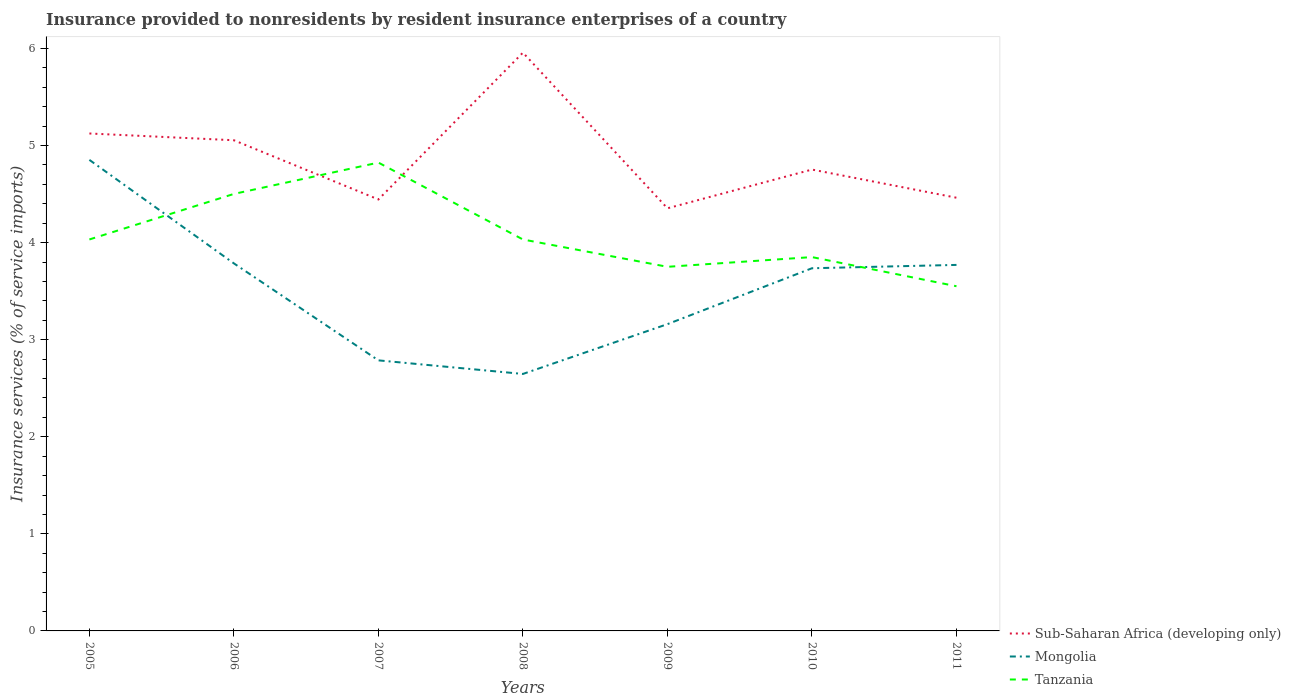How many different coloured lines are there?
Offer a very short reply. 3. Is the number of lines equal to the number of legend labels?
Offer a terse response. Yes. Across all years, what is the maximum insurance provided to nonresidents in Sub-Saharan Africa (developing only)?
Keep it short and to the point. 4.35. What is the total insurance provided to nonresidents in Tanzania in the graph?
Your answer should be very brief. 0.97. What is the difference between the highest and the second highest insurance provided to nonresidents in Tanzania?
Your answer should be compact. 1.27. Is the insurance provided to nonresidents in Tanzania strictly greater than the insurance provided to nonresidents in Mongolia over the years?
Your response must be concise. No. How many lines are there?
Your answer should be compact. 3. How many years are there in the graph?
Give a very brief answer. 7. Does the graph contain any zero values?
Provide a short and direct response. No. Where does the legend appear in the graph?
Provide a succinct answer. Bottom right. How many legend labels are there?
Provide a short and direct response. 3. What is the title of the graph?
Your answer should be compact. Insurance provided to nonresidents by resident insurance enterprises of a country. Does "Oman" appear as one of the legend labels in the graph?
Provide a succinct answer. No. What is the label or title of the X-axis?
Keep it short and to the point. Years. What is the label or title of the Y-axis?
Ensure brevity in your answer.  Insurance services (% of service imports). What is the Insurance services (% of service imports) in Sub-Saharan Africa (developing only) in 2005?
Provide a succinct answer. 5.12. What is the Insurance services (% of service imports) of Mongolia in 2005?
Offer a terse response. 4.85. What is the Insurance services (% of service imports) in Tanzania in 2005?
Offer a terse response. 4.03. What is the Insurance services (% of service imports) in Sub-Saharan Africa (developing only) in 2006?
Provide a succinct answer. 5.05. What is the Insurance services (% of service imports) in Mongolia in 2006?
Give a very brief answer. 3.79. What is the Insurance services (% of service imports) in Tanzania in 2006?
Give a very brief answer. 4.5. What is the Insurance services (% of service imports) of Sub-Saharan Africa (developing only) in 2007?
Give a very brief answer. 4.44. What is the Insurance services (% of service imports) in Mongolia in 2007?
Offer a terse response. 2.79. What is the Insurance services (% of service imports) of Tanzania in 2007?
Offer a terse response. 4.82. What is the Insurance services (% of service imports) in Sub-Saharan Africa (developing only) in 2008?
Your answer should be compact. 5.96. What is the Insurance services (% of service imports) in Mongolia in 2008?
Keep it short and to the point. 2.65. What is the Insurance services (% of service imports) in Tanzania in 2008?
Make the answer very short. 4.03. What is the Insurance services (% of service imports) in Sub-Saharan Africa (developing only) in 2009?
Your answer should be compact. 4.35. What is the Insurance services (% of service imports) of Mongolia in 2009?
Give a very brief answer. 3.16. What is the Insurance services (% of service imports) of Tanzania in 2009?
Keep it short and to the point. 3.75. What is the Insurance services (% of service imports) of Sub-Saharan Africa (developing only) in 2010?
Your response must be concise. 4.75. What is the Insurance services (% of service imports) of Mongolia in 2010?
Offer a very short reply. 3.74. What is the Insurance services (% of service imports) in Tanzania in 2010?
Ensure brevity in your answer.  3.85. What is the Insurance services (% of service imports) in Sub-Saharan Africa (developing only) in 2011?
Offer a very short reply. 4.46. What is the Insurance services (% of service imports) of Mongolia in 2011?
Give a very brief answer. 3.77. What is the Insurance services (% of service imports) in Tanzania in 2011?
Make the answer very short. 3.55. Across all years, what is the maximum Insurance services (% of service imports) in Sub-Saharan Africa (developing only)?
Offer a terse response. 5.96. Across all years, what is the maximum Insurance services (% of service imports) of Mongolia?
Give a very brief answer. 4.85. Across all years, what is the maximum Insurance services (% of service imports) of Tanzania?
Ensure brevity in your answer.  4.82. Across all years, what is the minimum Insurance services (% of service imports) of Sub-Saharan Africa (developing only)?
Provide a succinct answer. 4.35. Across all years, what is the minimum Insurance services (% of service imports) of Mongolia?
Provide a succinct answer. 2.65. Across all years, what is the minimum Insurance services (% of service imports) of Tanzania?
Your answer should be very brief. 3.55. What is the total Insurance services (% of service imports) in Sub-Saharan Africa (developing only) in the graph?
Provide a short and direct response. 34.15. What is the total Insurance services (% of service imports) in Mongolia in the graph?
Your answer should be compact. 24.74. What is the total Insurance services (% of service imports) of Tanzania in the graph?
Give a very brief answer. 28.54. What is the difference between the Insurance services (% of service imports) in Sub-Saharan Africa (developing only) in 2005 and that in 2006?
Your answer should be very brief. 0.07. What is the difference between the Insurance services (% of service imports) of Mongolia in 2005 and that in 2006?
Keep it short and to the point. 1.07. What is the difference between the Insurance services (% of service imports) in Tanzania in 2005 and that in 2006?
Your answer should be compact. -0.47. What is the difference between the Insurance services (% of service imports) in Sub-Saharan Africa (developing only) in 2005 and that in 2007?
Provide a succinct answer. 0.68. What is the difference between the Insurance services (% of service imports) of Mongolia in 2005 and that in 2007?
Offer a terse response. 2.07. What is the difference between the Insurance services (% of service imports) in Tanzania in 2005 and that in 2007?
Offer a very short reply. -0.79. What is the difference between the Insurance services (% of service imports) of Sub-Saharan Africa (developing only) in 2005 and that in 2008?
Give a very brief answer. -0.83. What is the difference between the Insurance services (% of service imports) in Mongolia in 2005 and that in 2008?
Offer a very short reply. 2.21. What is the difference between the Insurance services (% of service imports) in Sub-Saharan Africa (developing only) in 2005 and that in 2009?
Offer a very short reply. 0.77. What is the difference between the Insurance services (% of service imports) in Mongolia in 2005 and that in 2009?
Provide a succinct answer. 1.69. What is the difference between the Insurance services (% of service imports) in Tanzania in 2005 and that in 2009?
Provide a short and direct response. 0.28. What is the difference between the Insurance services (% of service imports) of Sub-Saharan Africa (developing only) in 2005 and that in 2010?
Provide a short and direct response. 0.37. What is the difference between the Insurance services (% of service imports) of Mongolia in 2005 and that in 2010?
Your response must be concise. 1.12. What is the difference between the Insurance services (% of service imports) of Tanzania in 2005 and that in 2010?
Offer a very short reply. 0.18. What is the difference between the Insurance services (% of service imports) of Sub-Saharan Africa (developing only) in 2005 and that in 2011?
Provide a succinct answer. 0.66. What is the difference between the Insurance services (% of service imports) in Mongolia in 2005 and that in 2011?
Make the answer very short. 1.08. What is the difference between the Insurance services (% of service imports) in Tanzania in 2005 and that in 2011?
Ensure brevity in your answer.  0.48. What is the difference between the Insurance services (% of service imports) in Sub-Saharan Africa (developing only) in 2006 and that in 2007?
Provide a short and direct response. 0.61. What is the difference between the Insurance services (% of service imports) in Tanzania in 2006 and that in 2007?
Give a very brief answer. -0.32. What is the difference between the Insurance services (% of service imports) in Sub-Saharan Africa (developing only) in 2006 and that in 2008?
Make the answer very short. -0.9. What is the difference between the Insurance services (% of service imports) in Mongolia in 2006 and that in 2008?
Give a very brief answer. 1.14. What is the difference between the Insurance services (% of service imports) in Tanzania in 2006 and that in 2008?
Your answer should be compact. 0.47. What is the difference between the Insurance services (% of service imports) of Sub-Saharan Africa (developing only) in 2006 and that in 2009?
Keep it short and to the point. 0.7. What is the difference between the Insurance services (% of service imports) of Mongolia in 2006 and that in 2009?
Keep it short and to the point. 0.63. What is the difference between the Insurance services (% of service imports) in Tanzania in 2006 and that in 2009?
Make the answer very short. 0.75. What is the difference between the Insurance services (% of service imports) of Sub-Saharan Africa (developing only) in 2006 and that in 2010?
Keep it short and to the point. 0.3. What is the difference between the Insurance services (% of service imports) in Mongolia in 2006 and that in 2010?
Offer a terse response. 0.05. What is the difference between the Insurance services (% of service imports) of Tanzania in 2006 and that in 2010?
Ensure brevity in your answer.  0.65. What is the difference between the Insurance services (% of service imports) in Sub-Saharan Africa (developing only) in 2006 and that in 2011?
Your response must be concise. 0.59. What is the difference between the Insurance services (% of service imports) of Mongolia in 2006 and that in 2011?
Your response must be concise. 0.02. What is the difference between the Insurance services (% of service imports) in Tanzania in 2006 and that in 2011?
Ensure brevity in your answer.  0.95. What is the difference between the Insurance services (% of service imports) in Sub-Saharan Africa (developing only) in 2007 and that in 2008?
Keep it short and to the point. -1.51. What is the difference between the Insurance services (% of service imports) of Mongolia in 2007 and that in 2008?
Your answer should be compact. 0.14. What is the difference between the Insurance services (% of service imports) in Tanzania in 2007 and that in 2008?
Offer a very short reply. 0.79. What is the difference between the Insurance services (% of service imports) in Sub-Saharan Africa (developing only) in 2007 and that in 2009?
Offer a terse response. 0.09. What is the difference between the Insurance services (% of service imports) of Mongolia in 2007 and that in 2009?
Ensure brevity in your answer.  -0.37. What is the difference between the Insurance services (% of service imports) in Tanzania in 2007 and that in 2009?
Ensure brevity in your answer.  1.07. What is the difference between the Insurance services (% of service imports) of Sub-Saharan Africa (developing only) in 2007 and that in 2010?
Your answer should be compact. -0.31. What is the difference between the Insurance services (% of service imports) in Mongolia in 2007 and that in 2010?
Your answer should be compact. -0.95. What is the difference between the Insurance services (% of service imports) in Tanzania in 2007 and that in 2010?
Keep it short and to the point. 0.97. What is the difference between the Insurance services (% of service imports) of Sub-Saharan Africa (developing only) in 2007 and that in 2011?
Keep it short and to the point. -0.02. What is the difference between the Insurance services (% of service imports) in Mongolia in 2007 and that in 2011?
Offer a terse response. -0.98. What is the difference between the Insurance services (% of service imports) of Tanzania in 2007 and that in 2011?
Your answer should be compact. 1.27. What is the difference between the Insurance services (% of service imports) of Sub-Saharan Africa (developing only) in 2008 and that in 2009?
Keep it short and to the point. 1.6. What is the difference between the Insurance services (% of service imports) of Mongolia in 2008 and that in 2009?
Your answer should be compact. -0.51. What is the difference between the Insurance services (% of service imports) in Tanzania in 2008 and that in 2009?
Your answer should be very brief. 0.28. What is the difference between the Insurance services (% of service imports) in Sub-Saharan Africa (developing only) in 2008 and that in 2010?
Provide a succinct answer. 1.2. What is the difference between the Insurance services (% of service imports) in Mongolia in 2008 and that in 2010?
Keep it short and to the point. -1.09. What is the difference between the Insurance services (% of service imports) in Tanzania in 2008 and that in 2010?
Your response must be concise. 0.18. What is the difference between the Insurance services (% of service imports) in Sub-Saharan Africa (developing only) in 2008 and that in 2011?
Provide a succinct answer. 1.49. What is the difference between the Insurance services (% of service imports) of Mongolia in 2008 and that in 2011?
Make the answer very short. -1.12. What is the difference between the Insurance services (% of service imports) in Tanzania in 2008 and that in 2011?
Give a very brief answer. 0.48. What is the difference between the Insurance services (% of service imports) in Sub-Saharan Africa (developing only) in 2009 and that in 2010?
Provide a short and direct response. -0.4. What is the difference between the Insurance services (% of service imports) of Mongolia in 2009 and that in 2010?
Provide a succinct answer. -0.58. What is the difference between the Insurance services (% of service imports) in Sub-Saharan Africa (developing only) in 2009 and that in 2011?
Keep it short and to the point. -0.11. What is the difference between the Insurance services (% of service imports) in Mongolia in 2009 and that in 2011?
Your answer should be very brief. -0.61. What is the difference between the Insurance services (% of service imports) of Tanzania in 2009 and that in 2011?
Ensure brevity in your answer.  0.2. What is the difference between the Insurance services (% of service imports) in Sub-Saharan Africa (developing only) in 2010 and that in 2011?
Give a very brief answer. 0.29. What is the difference between the Insurance services (% of service imports) of Mongolia in 2010 and that in 2011?
Keep it short and to the point. -0.03. What is the difference between the Insurance services (% of service imports) of Tanzania in 2010 and that in 2011?
Your answer should be compact. 0.3. What is the difference between the Insurance services (% of service imports) of Sub-Saharan Africa (developing only) in 2005 and the Insurance services (% of service imports) of Mongolia in 2006?
Keep it short and to the point. 1.34. What is the difference between the Insurance services (% of service imports) of Sub-Saharan Africa (developing only) in 2005 and the Insurance services (% of service imports) of Tanzania in 2006?
Keep it short and to the point. 0.62. What is the difference between the Insurance services (% of service imports) of Mongolia in 2005 and the Insurance services (% of service imports) of Tanzania in 2006?
Ensure brevity in your answer.  0.35. What is the difference between the Insurance services (% of service imports) of Sub-Saharan Africa (developing only) in 2005 and the Insurance services (% of service imports) of Mongolia in 2007?
Ensure brevity in your answer.  2.34. What is the difference between the Insurance services (% of service imports) of Sub-Saharan Africa (developing only) in 2005 and the Insurance services (% of service imports) of Tanzania in 2007?
Make the answer very short. 0.3. What is the difference between the Insurance services (% of service imports) of Mongolia in 2005 and the Insurance services (% of service imports) of Tanzania in 2007?
Offer a very short reply. 0.03. What is the difference between the Insurance services (% of service imports) in Sub-Saharan Africa (developing only) in 2005 and the Insurance services (% of service imports) in Mongolia in 2008?
Provide a short and direct response. 2.48. What is the difference between the Insurance services (% of service imports) of Sub-Saharan Africa (developing only) in 2005 and the Insurance services (% of service imports) of Tanzania in 2008?
Make the answer very short. 1.09. What is the difference between the Insurance services (% of service imports) in Mongolia in 2005 and the Insurance services (% of service imports) in Tanzania in 2008?
Your answer should be very brief. 0.82. What is the difference between the Insurance services (% of service imports) in Sub-Saharan Africa (developing only) in 2005 and the Insurance services (% of service imports) in Mongolia in 2009?
Ensure brevity in your answer.  1.96. What is the difference between the Insurance services (% of service imports) of Sub-Saharan Africa (developing only) in 2005 and the Insurance services (% of service imports) of Tanzania in 2009?
Provide a short and direct response. 1.37. What is the difference between the Insurance services (% of service imports) of Mongolia in 2005 and the Insurance services (% of service imports) of Tanzania in 2009?
Offer a terse response. 1.1. What is the difference between the Insurance services (% of service imports) in Sub-Saharan Africa (developing only) in 2005 and the Insurance services (% of service imports) in Mongolia in 2010?
Ensure brevity in your answer.  1.39. What is the difference between the Insurance services (% of service imports) of Sub-Saharan Africa (developing only) in 2005 and the Insurance services (% of service imports) of Tanzania in 2010?
Keep it short and to the point. 1.27. What is the difference between the Insurance services (% of service imports) in Sub-Saharan Africa (developing only) in 2005 and the Insurance services (% of service imports) in Mongolia in 2011?
Offer a very short reply. 1.35. What is the difference between the Insurance services (% of service imports) in Sub-Saharan Africa (developing only) in 2005 and the Insurance services (% of service imports) in Tanzania in 2011?
Ensure brevity in your answer.  1.57. What is the difference between the Insurance services (% of service imports) of Mongolia in 2005 and the Insurance services (% of service imports) of Tanzania in 2011?
Provide a short and direct response. 1.3. What is the difference between the Insurance services (% of service imports) of Sub-Saharan Africa (developing only) in 2006 and the Insurance services (% of service imports) of Mongolia in 2007?
Provide a succinct answer. 2.27. What is the difference between the Insurance services (% of service imports) of Sub-Saharan Africa (developing only) in 2006 and the Insurance services (% of service imports) of Tanzania in 2007?
Offer a terse response. 0.23. What is the difference between the Insurance services (% of service imports) in Mongolia in 2006 and the Insurance services (% of service imports) in Tanzania in 2007?
Your response must be concise. -1.04. What is the difference between the Insurance services (% of service imports) in Sub-Saharan Africa (developing only) in 2006 and the Insurance services (% of service imports) in Mongolia in 2008?
Ensure brevity in your answer.  2.41. What is the difference between the Insurance services (% of service imports) in Sub-Saharan Africa (developing only) in 2006 and the Insurance services (% of service imports) in Tanzania in 2008?
Give a very brief answer. 1.02. What is the difference between the Insurance services (% of service imports) in Mongolia in 2006 and the Insurance services (% of service imports) in Tanzania in 2008?
Give a very brief answer. -0.25. What is the difference between the Insurance services (% of service imports) of Sub-Saharan Africa (developing only) in 2006 and the Insurance services (% of service imports) of Mongolia in 2009?
Keep it short and to the point. 1.89. What is the difference between the Insurance services (% of service imports) in Sub-Saharan Africa (developing only) in 2006 and the Insurance services (% of service imports) in Tanzania in 2009?
Give a very brief answer. 1.3. What is the difference between the Insurance services (% of service imports) in Mongolia in 2006 and the Insurance services (% of service imports) in Tanzania in 2009?
Provide a succinct answer. 0.04. What is the difference between the Insurance services (% of service imports) of Sub-Saharan Africa (developing only) in 2006 and the Insurance services (% of service imports) of Mongolia in 2010?
Keep it short and to the point. 1.32. What is the difference between the Insurance services (% of service imports) in Sub-Saharan Africa (developing only) in 2006 and the Insurance services (% of service imports) in Tanzania in 2010?
Ensure brevity in your answer.  1.2. What is the difference between the Insurance services (% of service imports) of Mongolia in 2006 and the Insurance services (% of service imports) of Tanzania in 2010?
Your answer should be compact. -0.06. What is the difference between the Insurance services (% of service imports) in Sub-Saharan Africa (developing only) in 2006 and the Insurance services (% of service imports) in Mongolia in 2011?
Provide a short and direct response. 1.28. What is the difference between the Insurance services (% of service imports) of Sub-Saharan Africa (developing only) in 2006 and the Insurance services (% of service imports) of Tanzania in 2011?
Make the answer very short. 1.5. What is the difference between the Insurance services (% of service imports) of Mongolia in 2006 and the Insurance services (% of service imports) of Tanzania in 2011?
Offer a terse response. 0.24. What is the difference between the Insurance services (% of service imports) in Sub-Saharan Africa (developing only) in 2007 and the Insurance services (% of service imports) in Mongolia in 2008?
Provide a short and direct response. 1.8. What is the difference between the Insurance services (% of service imports) in Sub-Saharan Africa (developing only) in 2007 and the Insurance services (% of service imports) in Tanzania in 2008?
Your answer should be very brief. 0.41. What is the difference between the Insurance services (% of service imports) of Mongolia in 2007 and the Insurance services (% of service imports) of Tanzania in 2008?
Ensure brevity in your answer.  -1.25. What is the difference between the Insurance services (% of service imports) of Sub-Saharan Africa (developing only) in 2007 and the Insurance services (% of service imports) of Mongolia in 2009?
Provide a succinct answer. 1.28. What is the difference between the Insurance services (% of service imports) in Sub-Saharan Africa (developing only) in 2007 and the Insurance services (% of service imports) in Tanzania in 2009?
Your answer should be very brief. 0.69. What is the difference between the Insurance services (% of service imports) of Mongolia in 2007 and the Insurance services (% of service imports) of Tanzania in 2009?
Give a very brief answer. -0.96. What is the difference between the Insurance services (% of service imports) in Sub-Saharan Africa (developing only) in 2007 and the Insurance services (% of service imports) in Mongolia in 2010?
Make the answer very short. 0.71. What is the difference between the Insurance services (% of service imports) of Sub-Saharan Africa (developing only) in 2007 and the Insurance services (% of service imports) of Tanzania in 2010?
Keep it short and to the point. 0.59. What is the difference between the Insurance services (% of service imports) in Mongolia in 2007 and the Insurance services (% of service imports) in Tanzania in 2010?
Your answer should be very brief. -1.06. What is the difference between the Insurance services (% of service imports) in Sub-Saharan Africa (developing only) in 2007 and the Insurance services (% of service imports) in Mongolia in 2011?
Your answer should be very brief. 0.67. What is the difference between the Insurance services (% of service imports) of Sub-Saharan Africa (developing only) in 2007 and the Insurance services (% of service imports) of Tanzania in 2011?
Ensure brevity in your answer.  0.89. What is the difference between the Insurance services (% of service imports) in Mongolia in 2007 and the Insurance services (% of service imports) in Tanzania in 2011?
Provide a succinct answer. -0.76. What is the difference between the Insurance services (% of service imports) of Sub-Saharan Africa (developing only) in 2008 and the Insurance services (% of service imports) of Mongolia in 2009?
Your answer should be very brief. 2.8. What is the difference between the Insurance services (% of service imports) of Sub-Saharan Africa (developing only) in 2008 and the Insurance services (% of service imports) of Tanzania in 2009?
Give a very brief answer. 2.21. What is the difference between the Insurance services (% of service imports) of Mongolia in 2008 and the Insurance services (% of service imports) of Tanzania in 2009?
Make the answer very short. -1.1. What is the difference between the Insurance services (% of service imports) in Sub-Saharan Africa (developing only) in 2008 and the Insurance services (% of service imports) in Mongolia in 2010?
Give a very brief answer. 2.22. What is the difference between the Insurance services (% of service imports) of Sub-Saharan Africa (developing only) in 2008 and the Insurance services (% of service imports) of Tanzania in 2010?
Offer a terse response. 2.11. What is the difference between the Insurance services (% of service imports) of Mongolia in 2008 and the Insurance services (% of service imports) of Tanzania in 2010?
Your answer should be very brief. -1.2. What is the difference between the Insurance services (% of service imports) of Sub-Saharan Africa (developing only) in 2008 and the Insurance services (% of service imports) of Mongolia in 2011?
Make the answer very short. 2.19. What is the difference between the Insurance services (% of service imports) in Sub-Saharan Africa (developing only) in 2008 and the Insurance services (% of service imports) in Tanzania in 2011?
Offer a terse response. 2.41. What is the difference between the Insurance services (% of service imports) in Mongolia in 2008 and the Insurance services (% of service imports) in Tanzania in 2011?
Your answer should be compact. -0.9. What is the difference between the Insurance services (% of service imports) in Sub-Saharan Africa (developing only) in 2009 and the Insurance services (% of service imports) in Mongolia in 2010?
Make the answer very short. 0.62. What is the difference between the Insurance services (% of service imports) of Sub-Saharan Africa (developing only) in 2009 and the Insurance services (% of service imports) of Tanzania in 2010?
Your answer should be very brief. 0.5. What is the difference between the Insurance services (% of service imports) of Mongolia in 2009 and the Insurance services (% of service imports) of Tanzania in 2010?
Provide a short and direct response. -0.69. What is the difference between the Insurance services (% of service imports) in Sub-Saharan Africa (developing only) in 2009 and the Insurance services (% of service imports) in Mongolia in 2011?
Give a very brief answer. 0.58. What is the difference between the Insurance services (% of service imports) of Sub-Saharan Africa (developing only) in 2009 and the Insurance services (% of service imports) of Tanzania in 2011?
Keep it short and to the point. 0.8. What is the difference between the Insurance services (% of service imports) of Mongolia in 2009 and the Insurance services (% of service imports) of Tanzania in 2011?
Keep it short and to the point. -0.39. What is the difference between the Insurance services (% of service imports) in Sub-Saharan Africa (developing only) in 2010 and the Insurance services (% of service imports) in Mongolia in 2011?
Your response must be concise. 0.98. What is the difference between the Insurance services (% of service imports) of Sub-Saharan Africa (developing only) in 2010 and the Insurance services (% of service imports) of Tanzania in 2011?
Your answer should be very brief. 1.2. What is the difference between the Insurance services (% of service imports) of Mongolia in 2010 and the Insurance services (% of service imports) of Tanzania in 2011?
Your response must be concise. 0.19. What is the average Insurance services (% of service imports) of Sub-Saharan Africa (developing only) per year?
Offer a terse response. 4.88. What is the average Insurance services (% of service imports) of Mongolia per year?
Your answer should be very brief. 3.53. What is the average Insurance services (% of service imports) in Tanzania per year?
Offer a very short reply. 4.08. In the year 2005, what is the difference between the Insurance services (% of service imports) in Sub-Saharan Africa (developing only) and Insurance services (% of service imports) in Mongolia?
Keep it short and to the point. 0.27. In the year 2005, what is the difference between the Insurance services (% of service imports) of Sub-Saharan Africa (developing only) and Insurance services (% of service imports) of Tanzania?
Make the answer very short. 1.09. In the year 2005, what is the difference between the Insurance services (% of service imports) in Mongolia and Insurance services (% of service imports) in Tanzania?
Offer a terse response. 0.82. In the year 2006, what is the difference between the Insurance services (% of service imports) of Sub-Saharan Africa (developing only) and Insurance services (% of service imports) of Mongolia?
Your response must be concise. 1.27. In the year 2006, what is the difference between the Insurance services (% of service imports) of Sub-Saharan Africa (developing only) and Insurance services (% of service imports) of Tanzania?
Keep it short and to the point. 0.55. In the year 2006, what is the difference between the Insurance services (% of service imports) in Mongolia and Insurance services (% of service imports) in Tanzania?
Make the answer very short. -0.72. In the year 2007, what is the difference between the Insurance services (% of service imports) in Sub-Saharan Africa (developing only) and Insurance services (% of service imports) in Mongolia?
Offer a terse response. 1.66. In the year 2007, what is the difference between the Insurance services (% of service imports) of Sub-Saharan Africa (developing only) and Insurance services (% of service imports) of Tanzania?
Your answer should be very brief. -0.38. In the year 2007, what is the difference between the Insurance services (% of service imports) in Mongolia and Insurance services (% of service imports) in Tanzania?
Keep it short and to the point. -2.04. In the year 2008, what is the difference between the Insurance services (% of service imports) in Sub-Saharan Africa (developing only) and Insurance services (% of service imports) in Mongolia?
Offer a terse response. 3.31. In the year 2008, what is the difference between the Insurance services (% of service imports) of Sub-Saharan Africa (developing only) and Insurance services (% of service imports) of Tanzania?
Your response must be concise. 1.92. In the year 2008, what is the difference between the Insurance services (% of service imports) of Mongolia and Insurance services (% of service imports) of Tanzania?
Keep it short and to the point. -1.39. In the year 2009, what is the difference between the Insurance services (% of service imports) in Sub-Saharan Africa (developing only) and Insurance services (% of service imports) in Mongolia?
Ensure brevity in your answer.  1.19. In the year 2009, what is the difference between the Insurance services (% of service imports) in Sub-Saharan Africa (developing only) and Insurance services (% of service imports) in Tanzania?
Your answer should be very brief. 0.6. In the year 2009, what is the difference between the Insurance services (% of service imports) of Mongolia and Insurance services (% of service imports) of Tanzania?
Offer a terse response. -0.59. In the year 2010, what is the difference between the Insurance services (% of service imports) in Sub-Saharan Africa (developing only) and Insurance services (% of service imports) in Mongolia?
Offer a terse response. 1.02. In the year 2010, what is the difference between the Insurance services (% of service imports) in Sub-Saharan Africa (developing only) and Insurance services (% of service imports) in Tanzania?
Offer a very short reply. 0.9. In the year 2010, what is the difference between the Insurance services (% of service imports) of Mongolia and Insurance services (% of service imports) of Tanzania?
Make the answer very short. -0.11. In the year 2011, what is the difference between the Insurance services (% of service imports) of Sub-Saharan Africa (developing only) and Insurance services (% of service imports) of Mongolia?
Your answer should be compact. 0.69. In the year 2011, what is the difference between the Insurance services (% of service imports) of Sub-Saharan Africa (developing only) and Insurance services (% of service imports) of Tanzania?
Offer a very short reply. 0.91. In the year 2011, what is the difference between the Insurance services (% of service imports) of Mongolia and Insurance services (% of service imports) of Tanzania?
Your answer should be compact. 0.22. What is the ratio of the Insurance services (% of service imports) of Sub-Saharan Africa (developing only) in 2005 to that in 2006?
Your answer should be compact. 1.01. What is the ratio of the Insurance services (% of service imports) of Mongolia in 2005 to that in 2006?
Provide a succinct answer. 1.28. What is the ratio of the Insurance services (% of service imports) in Tanzania in 2005 to that in 2006?
Your answer should be compact. 0.9. What is the ratio of the Insurance services (% of service imports) in Sub-Saharan Africa (developing only) in 2005 to that in 2007?
Offer a very short reply. 1.15. What is the ratio of the Insurance services (% of service imports) of Mongolia in 2005 to that in 2007?
Give a very brief answer. 1.74. What is the ratio of the Insurance services (% of service imports) in Tanzania in 2005 to that in 2007?
Ensure brevity in your answer.  0.84. What is the ratio of the Insurance services (% of service imports) of Sub-Saharan Africa (developing only) in 2005 to that in 2008?
Keep it short and to the point. 0.86. What is the ratio of the Insurance services (% of service imports) in Mongolia in 2005 to that in 2008?
Offer a terse response. 1.83. What is the ratio of the Insurance services (% of service imports) of Tanzania in 2005 to that in 2008?
Your answer should be compact. 1. What is the ratio of the Insurance services (% of service imports) of Sub-Saharan Africa (developing only) in 2005 to that in 2009?
Your answer should be very brief. 1.18. What is the ratio of the Insurance services (% of service imports) in Mongolia in 2005 to that in 2009?
Make the answer very short. 1.54. What is the ratio of the Insurance services (% of service imports) of Tanzania in 2005 to that in 2009?
Your response must be concise. 1.08. What is the ratio of the Insurance services (% of service imports) of Sub-Saharan Africa (developing only) in 2005 to that in 2010?
Make the answer very short. 1.08. What is the ratio of the Insurance services (% of service imports) of Mongolia in 2005 to that in 2010?
Ensure brevity in your answer.  1.3. What is the ratio of the Insurance services (% of service imports) in Tanzania in 2005 to that in 2010?
Your answer should be compact. 1.05. What is the ratio of the Insurance services (% of service imports) of Sub-Saharan Africa (developing only) in 2005 to that in 2011?
Ensure brevity in your answer.  1.15. What is the ratio of the Insurance services (% of service imports) in Mongolia in 2005 to that in 2011?
Your answer should be very brief. 1.29. What is the ratio of the Insurance services (% of service imports) in Tanzania in 2005 to that in 2011?
Offer a terse response. 1.14. What is the ratio of the Insurance services (% of service imports) of Sub-Saharan Africa (developing only) in 2006 to that in 2007?
Your response must be concise. 1.14. What is the ratio of the Insurance services (% of service imports) of Mongolia in 2006 to that in 2007?
Provide a succinct answer. 1.36. What is the ratio of the Insurance services (% of service imports) of Tanzania in 2006 to that in 2007?
Provide a short and direct response. 0.93. What is the ratio of the Insurance services (% of service imports) in Sub-Saharan Africa (developing only) in 2006 to that in 2008?
Your answer should be compact. 0.85. What is the ratio of the Insurance services (% of service imports) of Mongolia in 2006 to that in 2008?
Your response must be concise. 1.43. What is the ratio of the Insurance services (% of service imports) in Tanzania in 2006 to that in 2008?
Your response must be concise. 1.12. What is the ratio of the Insurance services (% of service imports) of Sub-Saharan Africa (developing only) in 2006 to that in 2009?
Your answer should be compact. 1.16. What is the ratio of the Insurance services (% of service imports) of Mongolia in 2006 to that in 2009?
Offer a terse response. 1.2. What is the ratio of the Insurance services (% of service imports) in Tanzania in 2006 to that in 2009?
Offer a terse response. 1.2. What is the ratio of the Insurance services (% of service imports) in Sub-Saharan Africa (developing only) in 2006 to that in 2010?
Give a very brief answer. 1.06. What is the ratio of the Insurance services (% of service imports) of Mongolia in 2006 to that in 2010?
Keep it short and to the point. 1.01. What is the ratio of the Insurance services (% of service imports) in Tanzania in 2006 to that in 2010?
Your response must be concise. 1.17. What is the ratio of the Insurance services (% of service imports) in Sub-Saharan Africa (developing only) in 2006 to that in 2011?
Offer a terse response. 1.13. What is the ratio of the Insurance services (% of service imports) in Tanzania in 2006 to that in 2011?
Your response must be concise. 1.27. What is the ratio of the Insurance services (% of service imports) in Sub-Saharan Africa (developing only) in 2007 to that in 2008?
Offer a terse response. 0.75. What is the ratio of the Insurance services (% of service imports) in Mongolia in 2007 to that in 2008?
Ensure brevity in your answer.  1.05. What is the ratio of the Insurance services (% of service imports) of Tanzania in 2007 to that in 2008?
Your response must be concise. 1.2. What is the ratio of the Insurance services (% of service imports) in Sub-Saharan Africa (developing only) in 2007 to that in 2009?
Provide a short and direct response. 1.02. What is the ratio of the Insurance services (% of service imports) of Mongolia in 2007 to that in 2009?
Provide a succinct answer. 0.88. What is the ratio of the Insurance services (% of service imports) of Tanzania in 2007 to that in 2009?
Your response must be concise. 1.29. What is the ratio of the Insurance services (% of service imports) in Sub-Saharan Africa (developing only) in 2007 to that in 2010?
Your answer should be very brief. 0.94. What is the ratio of the Insurance services (% of service imports) in Mongolia in 2007 to that in 2010?
Keep it short and to the point. 0.75. What is the ratio of the Insurance services (% of service imports) of Tanzania in 2007 to that in 2010?
Give a very brief answer. 1.25. What is the ratio of the Insurance services (% of service imports) in Mongolia in 2007 to that in 2011?
Keep it short and to the point. 0.74. What is the ratio of the Insurance services (% of service imports) of Tanzania in 2007 to that in 2011?
Ensure brevity in your answer.  1.36. What is the ratio of the Insurance services (% of service imports) in Sub-Saharan Africa (developing only) in 2008 to that in 2009?
Your answer should be compact. 1.37. What is the ratio of the Insurance services (% of service imports) in Mongolia in 2008 to that in 2009?
Provide a succinct answer. 0.84. What is the ratio of the Insurance services (% of service imports) of Tanzania in 2008 to that in 2009?
Provide a succinct answer. 1.07. What is the ratio of the Insurance services (% of service imports) in Sub-Saharan Africa (developing only) in 2008 to that in 2010?
Provide a short and direct response. 1.25. What is the ratio of the Insurance services (% of service imports) in Mongolia in 2008 to that in 2010?
Your answer should be very brief. 0.71. What is the ratio of the Insurance services (% of service imports) of Tanzania in 2008 to that in 2010?
Ensure brevity in your answer.  1.05. What is the ratio of the Insurance services (% of service imports) in Sub-Saharan Africa (developing only) in 2008 to that in 2011?
Your answer should be compact. 1.33. What is the ratio of the Insurance services (% of service imports) in Mongolia in 2008 to that in 2011?
Give a very brief answer. 0.7. What is the ratio of the Insurance services (% of service imports) of Tanzania in 2008 to that in 2011?
Your answer should be very brief. 1.14. What is the ratio of the Insurance services (% of service imports) of Sub-Saharan Africa (developing only) in 2009 to that in 2010?
Offer a very short reply. 0.92. What is the ratio of the Insurance services (% of service imports) in Mongolia in 2009 to that in 2010?
Your answer should be compact. 0.85. What is the ratio of the Insurance services (% of service imports) in Sub-Saharan Africa (developing only) in 2009 to that in 2011?
Offer a terse response. 0.98. What is the ratio of the Insurance services (% of service imports) of Mongolia in 2009 to that in 2011?
Offer a very short reply. 0.84. What is the ratio of the Insurance services (% of service imports) in Tanzania in 2009 to that in 2011?
Offer a very short reply. 1.06. What is the ratio of the Insurance services (% of service imports) of Sub-Saharan Africa (developing only) in 2010 to that in 2011?
Keep it short and to the point. 1.06. What is the ratio of the Insurance services (% of service imports) of Mongolia in 2010 to that in 2011?
Provide a succinct answer. 0.99. What is the ratio of the Insurance services (% of service imports) of Tanzania in 2010 to that in 2011?
Keep it short and to the point. 1.08. What is the difference between the highest and the second highest Insurance services (% of service imports) in Sub-Saharan Africa (developing only)?
Keep it short and to the point. 0.83. What is the difference between the highest and the second highest Insurance services (% of service imports) of Mongolia?
Make the answer very short. 1.07. What is the difference between the highest and the second highest Insurance services (% of service imports) of Tanzania?
Your answer should be very brief. 0.32. What is the difference between the highest and the lowest Insurance services (% of service imports) in Sub-Saharan Africa (developing only)?
Ensure brevity in your answer.  1.6. What is the difference between the highest and the lowest Insurance services (% of service imports) of Mongolia?
Offer a terse response. 2.21. What is the difference between the highest and the lowest Insurance services (% of service imports) in Tanzania?
Offer a terse response. 1.27. 